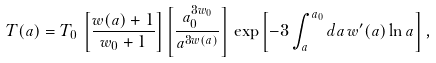<formula> <loc_0><loc_0><loc_500><loc_500>T ( a ) = T _ { 0 } \, \left [ \frac { w ( a ) + 1 } { w _ { 0 } + 1 } \right ] \left [ \frac { a _ { 0 } ^ { 3 w _ { 0 } } } { a ^ { 3 w ( a ) } } \right ] \, \exp \left [ - 3 \int _ { a } ^ { a _ { 0 } } d a \, w ^ { \prime } ( a ) \ln a \right ] ,</formula> 